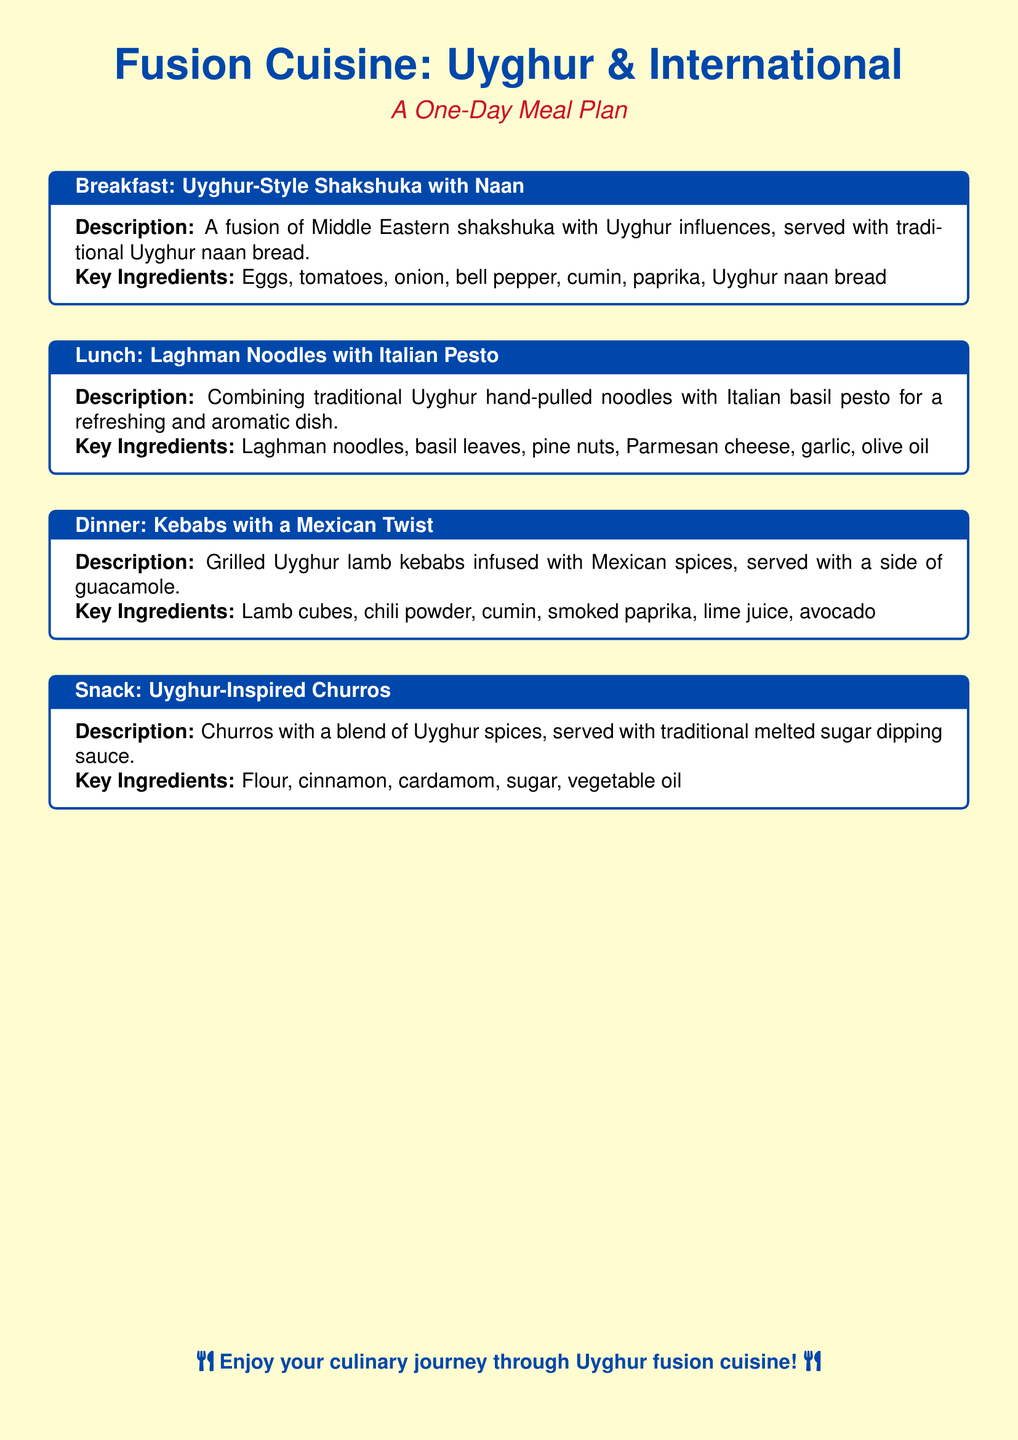What is served for breakfast? The meal plan indicates that breakfast consists of Uyghur-Style Shakshuka with Naan.
Answer: Uyghur-Style Shakshuka with Naan What type of noodles are used in lunch? The document states that Laghman noodles are used in the lunch meal.
Answer: Laghman noodles What type of meat is used in the dinner dish? The meal plan specifies that lamb is the type of meat used in the dinner dish.
Answer: Lamb What dip is mentioned as a side for dinner? The document mentions guacamole as a side dip for the kebabs.
Answer: Guacamole What spice is included in the snack churros? The meal plan lists cardamom as one of the spices in the Uyghur-inspired churros.
Answer: Cardamom How many meals are included in the plan? The document includes a total of four distinct meals: breakfast, lunch, dinner, and snack.
Answer: Four What is the main cuisine style featured in the meal plan? The document highlights Fusion Cuisine as the main theme of the meal plan.
Answer: Fusion Cuisine Which dish combines Uyghur and Italian cuisine? The meal plan indicates that Laghman noodles with Italian Pesto is the dish that combines both cuisines.
Answer: Laghman Noodles with Italian Pesto What is the key ingredient for the breakfast dish? The main ingredient listed for the breakfast dish is eggs.
Answer: Eggs 